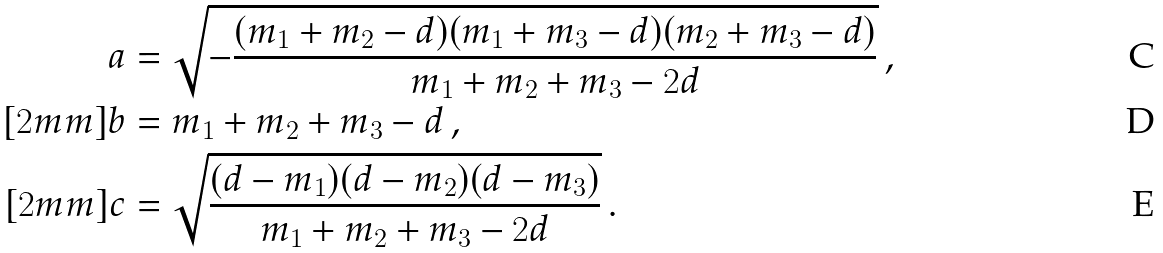<formula> <loc_0><loc_0><loc_500><loc_500>a & = \sqrt { - \frac { ( m _ { 1 } + m _ { 2 } - d ) ( m _ { 1 } + m _ { 3 } - d ) ( m _ { 2 } + m _ { 3 } - d ) } { m _ { 1 } + m _ { 2 } + m _ { 3 } - 2 d } } \, , \\ [ 2 m m ] b & = m _ { 1 } + m _ { 2 } + m _ { 3 } - d \, , \\ [ 2 m m ] c & = \sqrt { \frac { ( d - m _ { 1 } ) ( d - m _ { 2 } ) ( d - m _ { 3 } ) } { m _ { 1 } + m _ { 2 } + m _ { 3 } - 2 d } } \, .</formula> 